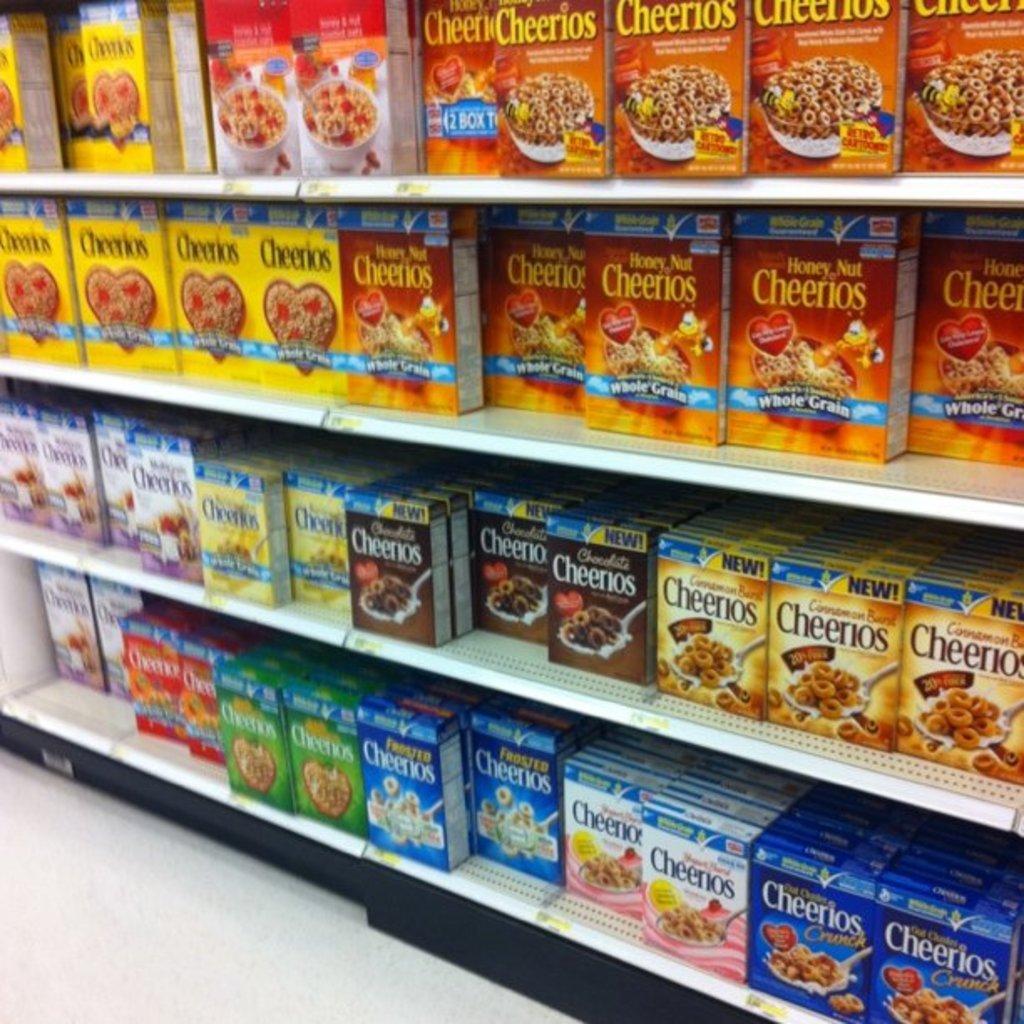How many types of cheerios are there?
Keep it short and to the point. 12. What kind of cheerios are in the brown box?
Provide a succinct answer. Chocolate. 